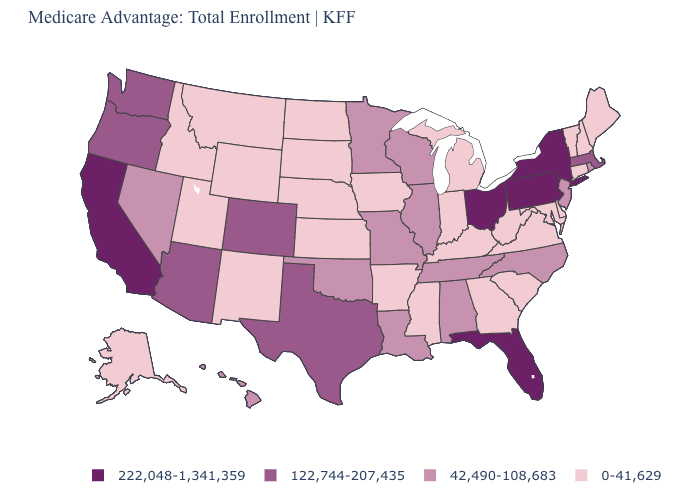Among the states that border Nebraska , does Colorado have the highest value?
Concise answer only. Yes. Name the states that have a value in the range 42,490-108,683?
Write a very short answer. Alabama, Hawaii, Illinois, Louisiana, Minnesota, Missouri, North Carolina, New Jersey, Nevada, Oklahoma, Rhode Island, Tennessee, Wisconsin. What is the value of Massachusetts?
Keep it brief. 122,744-207,435. Does Vermont have the lowest value in the USA?
Keep it brief. Yes. What is the highest value in the Northeast ?
Write a very short answer. 222,048-1,341,359. Does the map have missing data?
Short answer required. No. Among the states that border New Hampshire , does Vermont have the lowest value?
Quick response, please. Yes. What is the value of Virginia?
Concise answer only. 0-41,629. Which states hav the highest value in the South?
Write a very short answer. Florida. Among the states that border California , does Nevada have the highest value?
Concise answer only. No. Does California have the highest value in the USA?
Quick response, please. Yes. What is the value of Kansas?
Be succinct. 0-41,629. What is the lowest value in the USA?
Write a very short answer. 0-41,629. What is the value of Texas?
Concise answer only. 122,744-207,435. Which states have the highest value in the USA?
Quick response, please. California, Florida, New York, Ohio, Pennsylvania. 